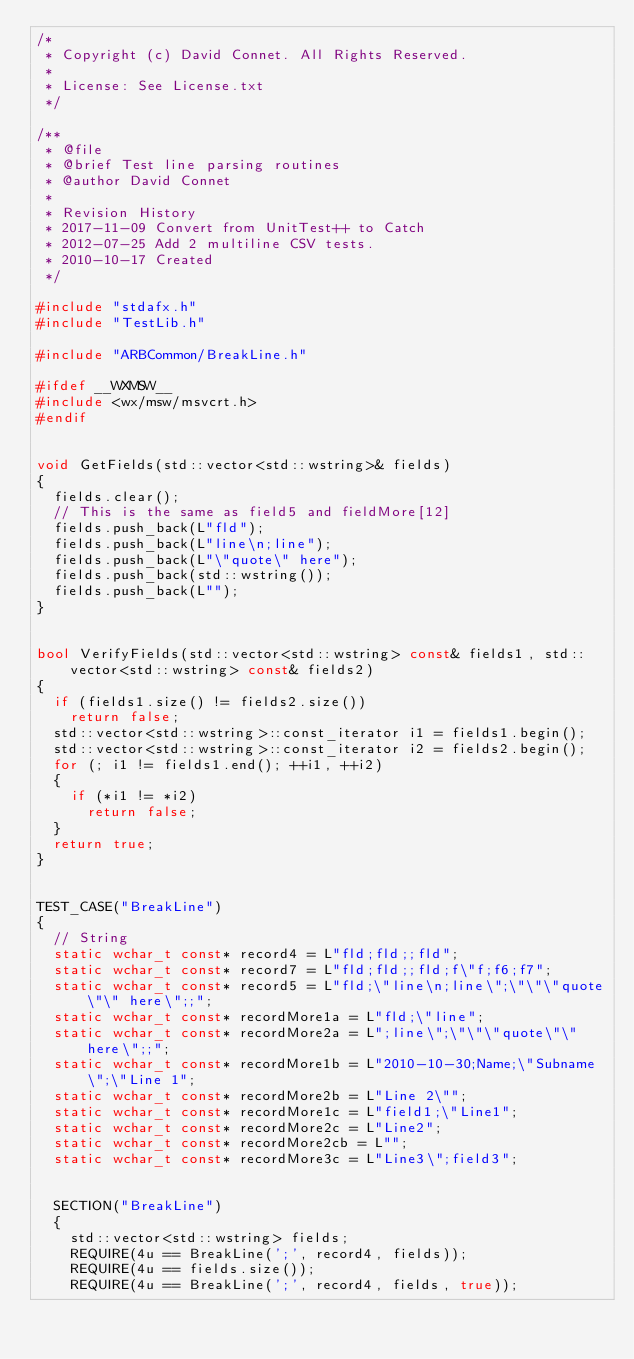<code> <loc_0><loc_0><loc_500><loc_500><_C++_>/*
 * Copyright (c) David Connet. All Rights Reserved.
 *
 * License: See License.txt
 */

/**
 * @file
 * @brief Test line parsing routines
 * @author David Connet
 *
 * Revision History
 * 2017-11-09 Convert from UnitTest++ to Catch
 * 2012-07-25 Add 2 multiline CSV tests.
 * 2010-10-17 Created
 */

#include "stdafx.h"
#include "TestLib.h"

#include "ARBCommon/BreakLine.h"

#ifdef __WXMSW__
#include <wx/msw/msvcrt.h>
#endif


void GetFields(std::vector<std::wstring>& fields)
{
	fields.clear();
	// This is the same as field5 and fieldMore[12]
	fields.push_back(L"fld");
	fields.push_back(L"line\n;line");
	fields.push_back(L"\"quote\" here");
	fields.push_back(std::wstring());
	fields.push_back(L"");
}


bool VerifyFields(std::vector<std::wstring> const& fields1, std::vector<std::wstring> const& fields2)
{
	if (fields1.size() != fields2.size())
		return false;
	std::vector<std::wstring>::const_iterator i1 = fields1.begin();
	std::vector<std::wstring>::const_iterator i2 = fields2.begin();
	for (; i1 != fields1.end(); ++i1, ++i2)
	{
		if (*i1 != *i2)
			return false;
	}
	return true;
}


TEST_CASE("BreakLine")
{
	// String
	static wchar_t const* record4 = L"fld;fld;;fld";
	static wchar_t const* record7 = L"fld;fld;;fld;f\"f;f6;f7";
	static wchar_t const* record5 = L"fld;\"line\n;line\";\"\"\"quote\"\" here\";;";
	static wchar_t const* recordMore1a = L"fld;\"line";
	static wchar_t const* recordMore2a = L";line\";\"\"\"quote\"\" here\";;";
	static wchar_t const* recordMore1b = L"2010-10-30;Name;\"Subname\";\"Line 1";
	static wchar_t const* recordMore2b = L"Line 2\"";
	static wchar_t const* recordMore1c = L"field1;\"Line1";
	static wchar_t const* recordMore2c = L"Line2";
	static wchar_t const* recordMore2cb = L"";
	static wchar_t const* recordMore3c = L"Line3\";field3";


	SECTION("BreakLine")
	{
		std::vector<std::wstring> fields;
		REQUIRE(4u == BreakLine(';', record4, fields));
		REQUIRE(4u == fields.size());
		REQUIRE(4u == BreakLine(';', record4, fields, true));</code> 